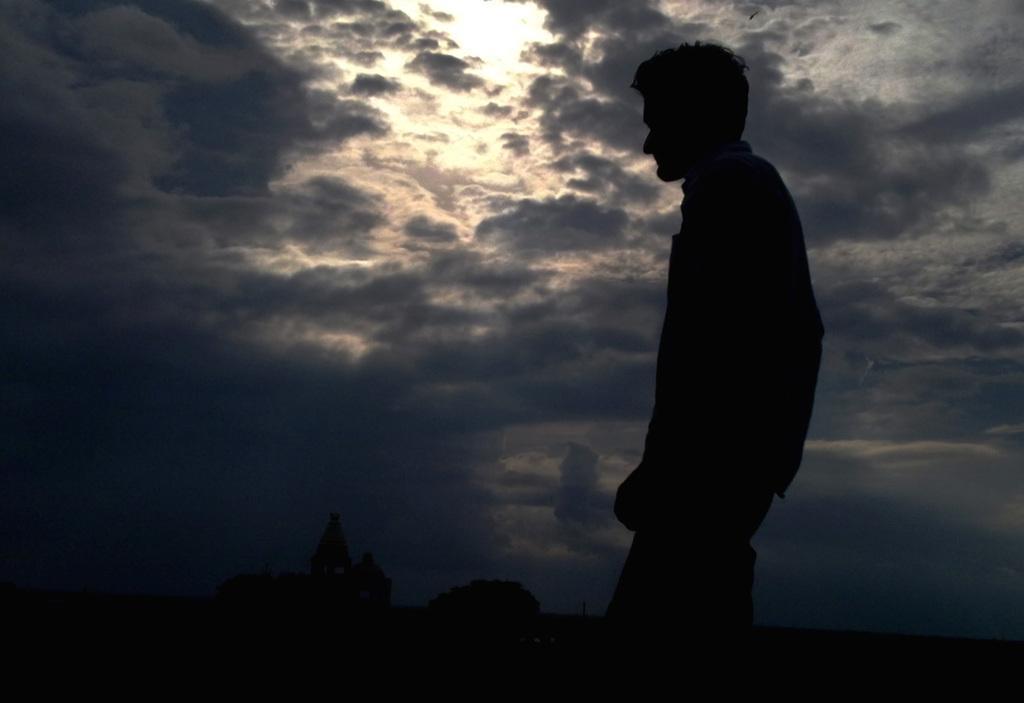Please provide a concise description of this image. In this image we can see a man. The sky is covered with clouds. At the bottom of the image, we can see a building and a tree. 